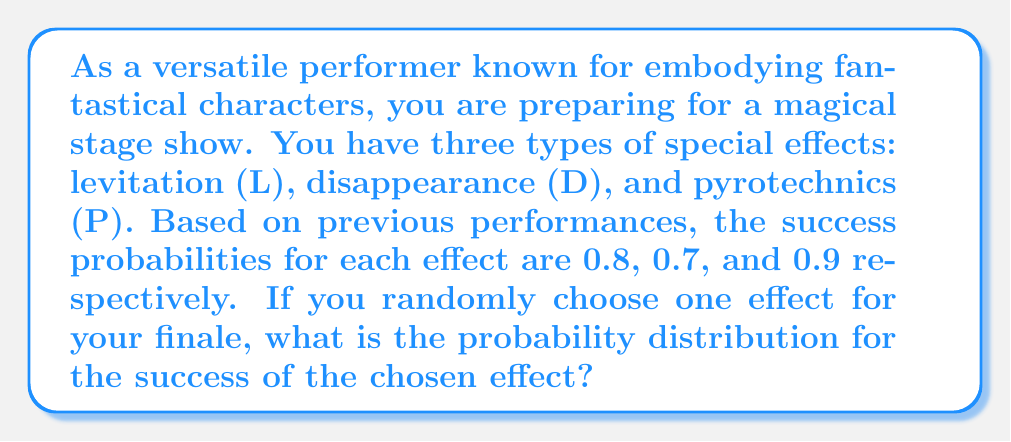Could you help me with this problem? Let's approach this step-by-step:

1) First, we need to define our random variable. Let X be the event of a successful special effect.

2) We have three possible outcomes:
   - X = L (Levitation succeeds)
   - X = D (Disappearance succeeds)
   - X = P (Pyrotechnics succeeds)

3) The probability of choosing each effect is equal (random choice), so P(choosing L) = P(choosing D) = P(choosing P) = 1/3

4) Now, let's calculate the probability for each outcome:

   P(X = L) = P(choosing L) × P(L succeeding)
             = 1/3 × 0.8 = 0.2667

   P(X = D) = P(choosing D) × P(D succeeding)
             = 1/3 × 0.7 = 0.2333

   P(X = P) = P(choosing P) × P(P succeeding)
             = 1/3 × 0.9 = 0.3000

5) We can represent this as a probability distribution:

   $$P(X) = \begin{cases}
   0.2667, & \text{if X = L} \\
   0.2333, & \text{if X = D} \\
   0.3000, & \text{if X = P}
   \end{cases}$$

6) We can verify that these probabilities sum to 1:
   0.2667 + 0.2333 + 0.3000 = 0.8000

   The remaining 0.2000 probability represents the chance of the chosen effect failing.
Answer: $$P(X) = \begin{cases}
0.2667, & \text{if X = L} \\
0.2333, & \text{if X = D} \\
0.3000, & \text{if X = P}
\end{cases}$$ 